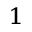<formula> <loc_0><loc_0><loc_500><loc_500>^ { 1 }</formula> 